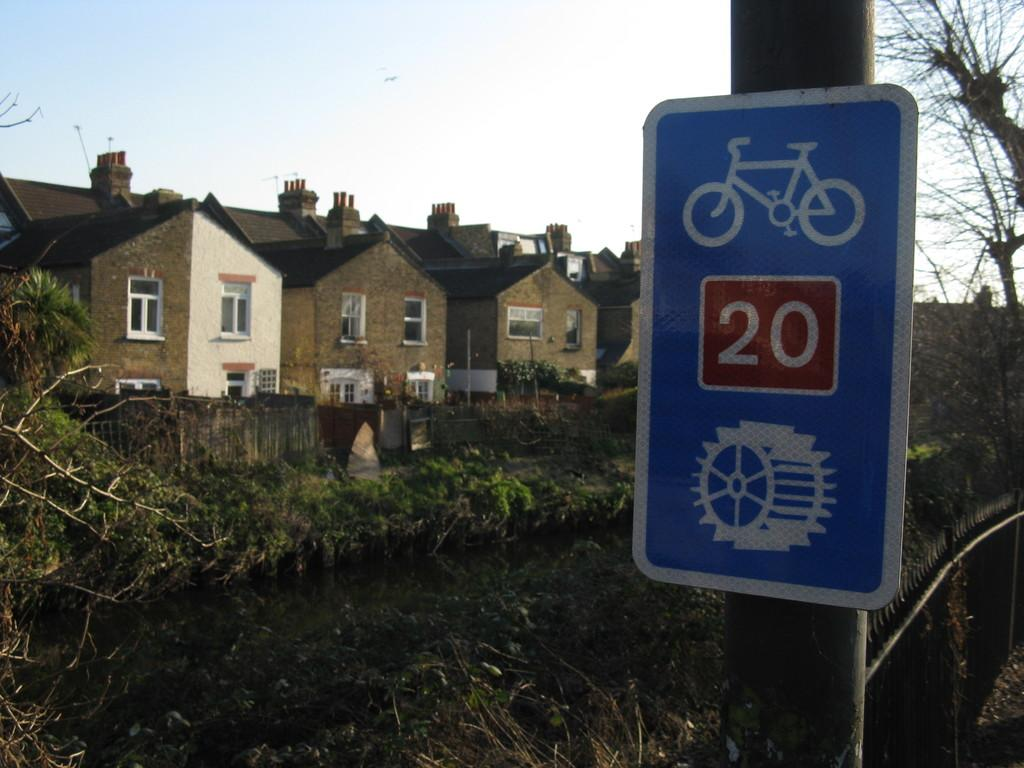<image>
Present a compact description of the photo's key features. A blue sign is behind a row of houses and says 20 on it. 